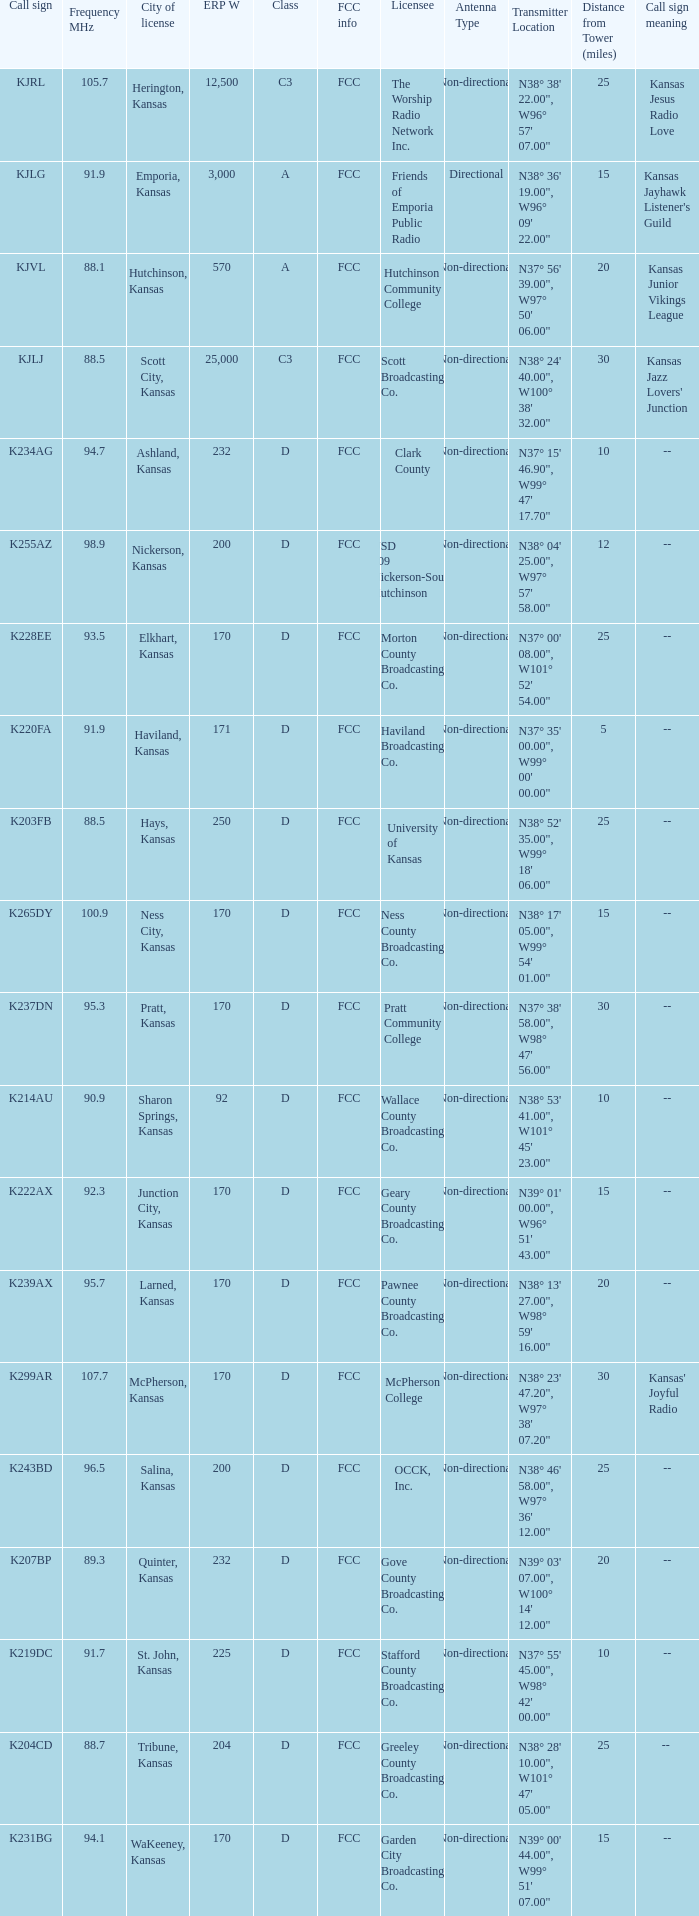Class of d, and a Frequency MHz smaller than 107.7, and a ERP W smaller than 232 has what call sign? K255AZ, K228EE, K220FA, K265DY, K237DN, K214AU, K222AX, K239AX, K243BD, K219DC, K204CD, K231BG. 